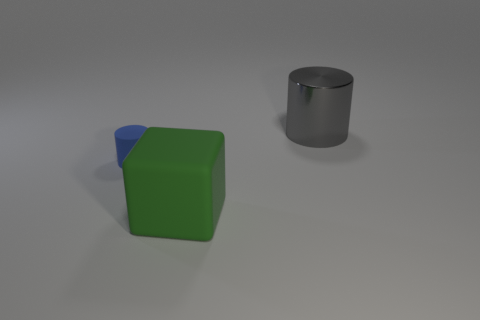There is a big object on the left side of the cylinder to the right of the big object that is in front of the shiny cylinder; what is its material?
Give a very brief answer. Rubber. How many other objects are the same shape as the large matte object?
Offer a terse response. 0. There is a cylinder that is in front of the gray thing; what color is it?
Keep it short and to the point. Blue. There is a thing that is left of the big thing in front of the large gray cylinder; how many green matte objects are on the right side of it?
Make the answer very short. 1. What number of green matte blocks are left of the cylinder to the left of the metal cylinder?
Provide a succinct answer. 0. There is a large green matte object; how many big gray metal objects are in front of it?
Your answer should be compact. 0. What number of other things are there of the same size as the blue cylinder?
Provide a succinct answer. 0. The other metallic thing that is the same shape as the tiny thing is what size?
Keep it short and to the point. Large. The big object to the right of the large green rubber thing has what shape?
Your response must be concise. Cylinder. What is the color of the thing in front of the cylinder that is on the left side of the big shiny object?
Provide a succinct answer. Green. 